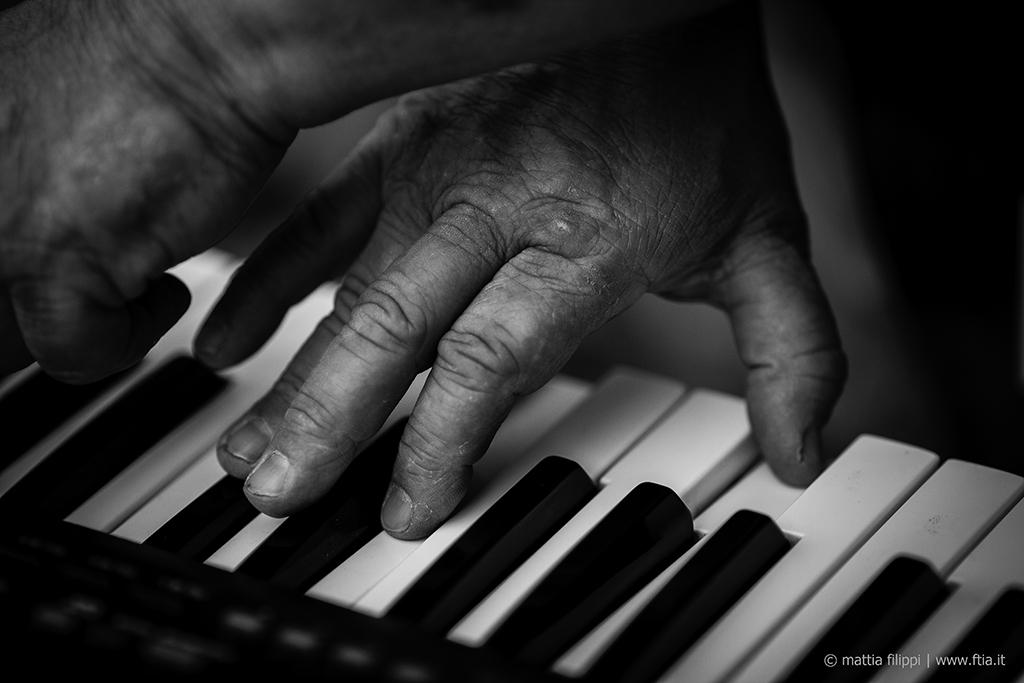What is the man in the image doing? There is a man playing a piano in the image. What instrument is the man playing? The man is playing a piano. Can you describe the man's activity in the image? The man is sitting at the piano and using his hands to play the keys. What type of cactus is sitting next to the man while he plays the piano? There is no cactus present in the image; the man is playing the piano alone. 